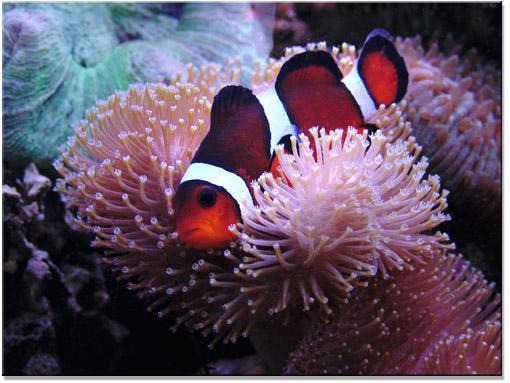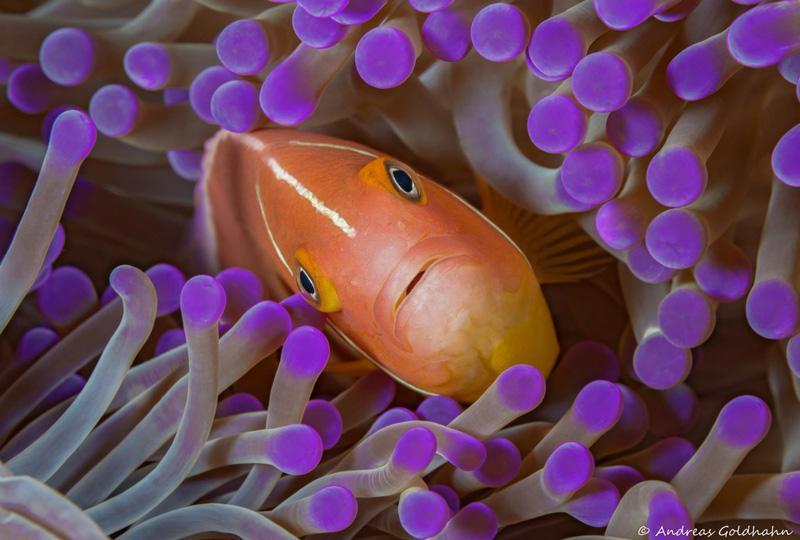The first image is the image on the left, the second image is the image on the right. For the images shown, is this caption "Exactly two fish are seen hiding in the sea plant." true? Answer yes or no. Yes. The first image is the image on the left, the second image is the image on the right. For the images shown, is this caption "Left image shows an orange fish with one white stripe swimming among lavender-colored tendrils." true? Answer yes or no. No. 